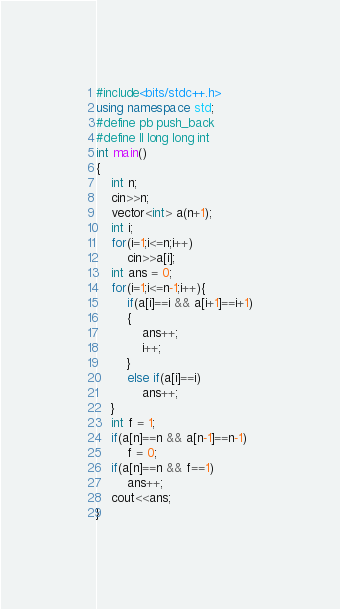Convert code to text. <code><loc_0><loc_0><loc_500><loc_500><_C++_>#include<bits/stdc++.h>
using namespace std;
#define pb push_back
#define ll long long int
int main()
{
	int n;
	cin>>n;
	vector<int> a(n+1);
	int i;
	for(i=1;i<=n;i++)
		cin>>a[i];
	int ans = 0;
	for(i=1;i<=n-1;i++){
		if(a[i]==i && a[i+1]==i+1)
		{
			ans++;
			i++;
		}
		else if(a[i]==i)
			ans++;
	}
	int f = 1;
	if(a[n]==n && a[n-1]==n-1)
		f = 0;
	if(a[n]==n && f==1)
		ans++;
	cout<<ans;
}</code> 